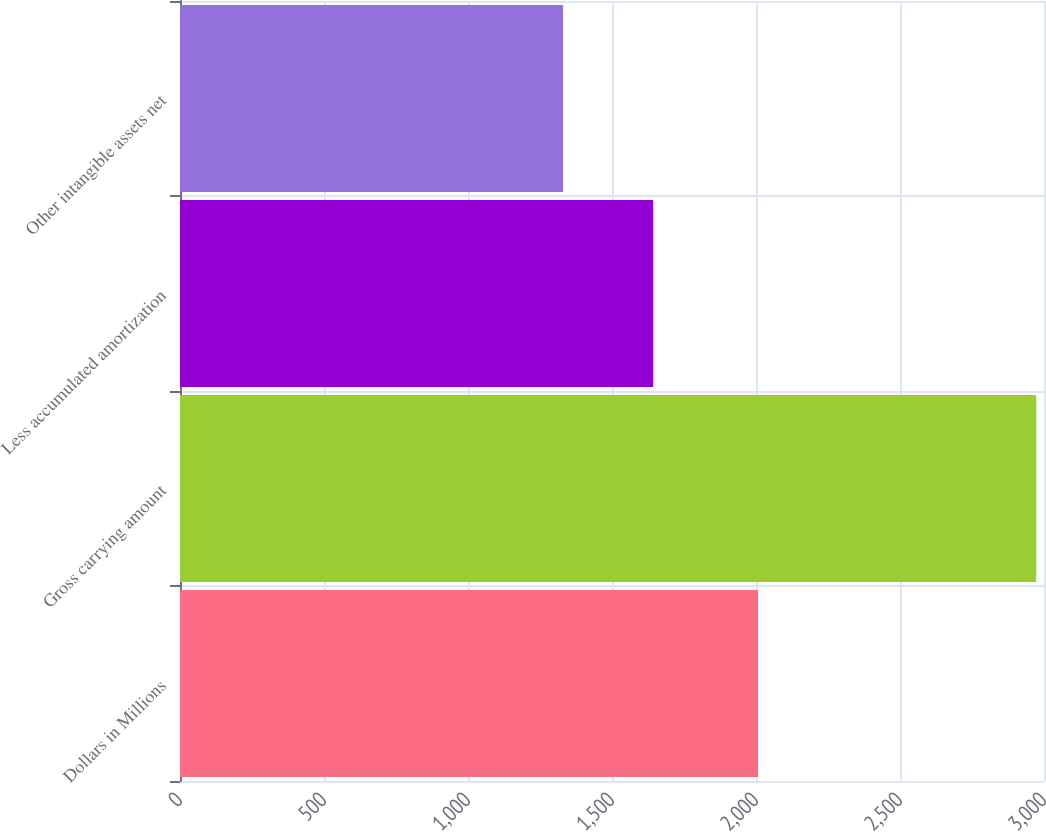Convert chart to OTSL. <chart><loc_0><loc_0><loc_500><loc_500><bar_chart><fcel>Dollars in Millions<fcel>Gross carrying amount<fcel>Less accumulated amortization<fcel>Other intangible assets net<nl><fcel>2007<fcel>2973<fcel>1643<fcel>1330<nl></chart> 